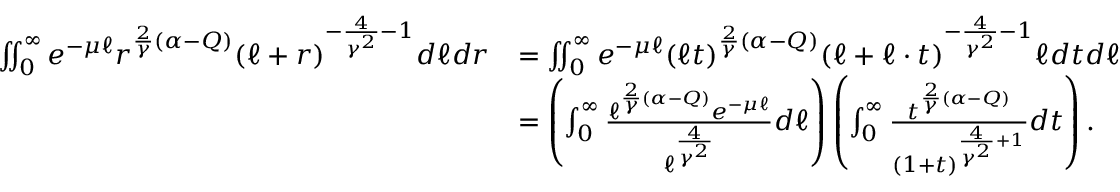<formula> <loc_0><loc_0><loc_500><loc_500>\begin{array} { r l } { \iint _ { 0 } ^ { \infty } e ^ { - \mu \ell } r ^ { \frac { 2 } { \gamma } ( \alpha - Q ) } ( \ell + r ) ^ { - \frac { 4 } { \gamma ^ { 2 } } - 1 } d \ell d r } & { = \iint _ { 0 } ^ { \infty } e ^ { - \mu \ell } ( \ell t ) ^ { \frac { 2 } { \gamma } ( \alpha - Q ) } ( \ell + \ell \cdot t ) ^ { - \frac { 4 } { \gamma ^ { 2 } } - 1 } \ell d t d \ell } \\ & { = \left ( \int _ { 0 } ^ { \infty } \frac { \ell ^ { \frac { 2 } { \gamma } ( \alpha - Q ) } e ^ { - \mu \ell } } { \ell ^ { \frac { 4 } { \gamma ^ { 2 } } } } d \ell \right ) \left ( \int _ { 0 } ^ { \infty } \frac { t ^ { \frac { 2 } { \gamma } ( \alpha - Q ) } } { ( 1 + t ) ^ { \frac { 4 } { \gamma ^ { 2 } } + 1 } } d t \right ) . } \end{array}</formula> 